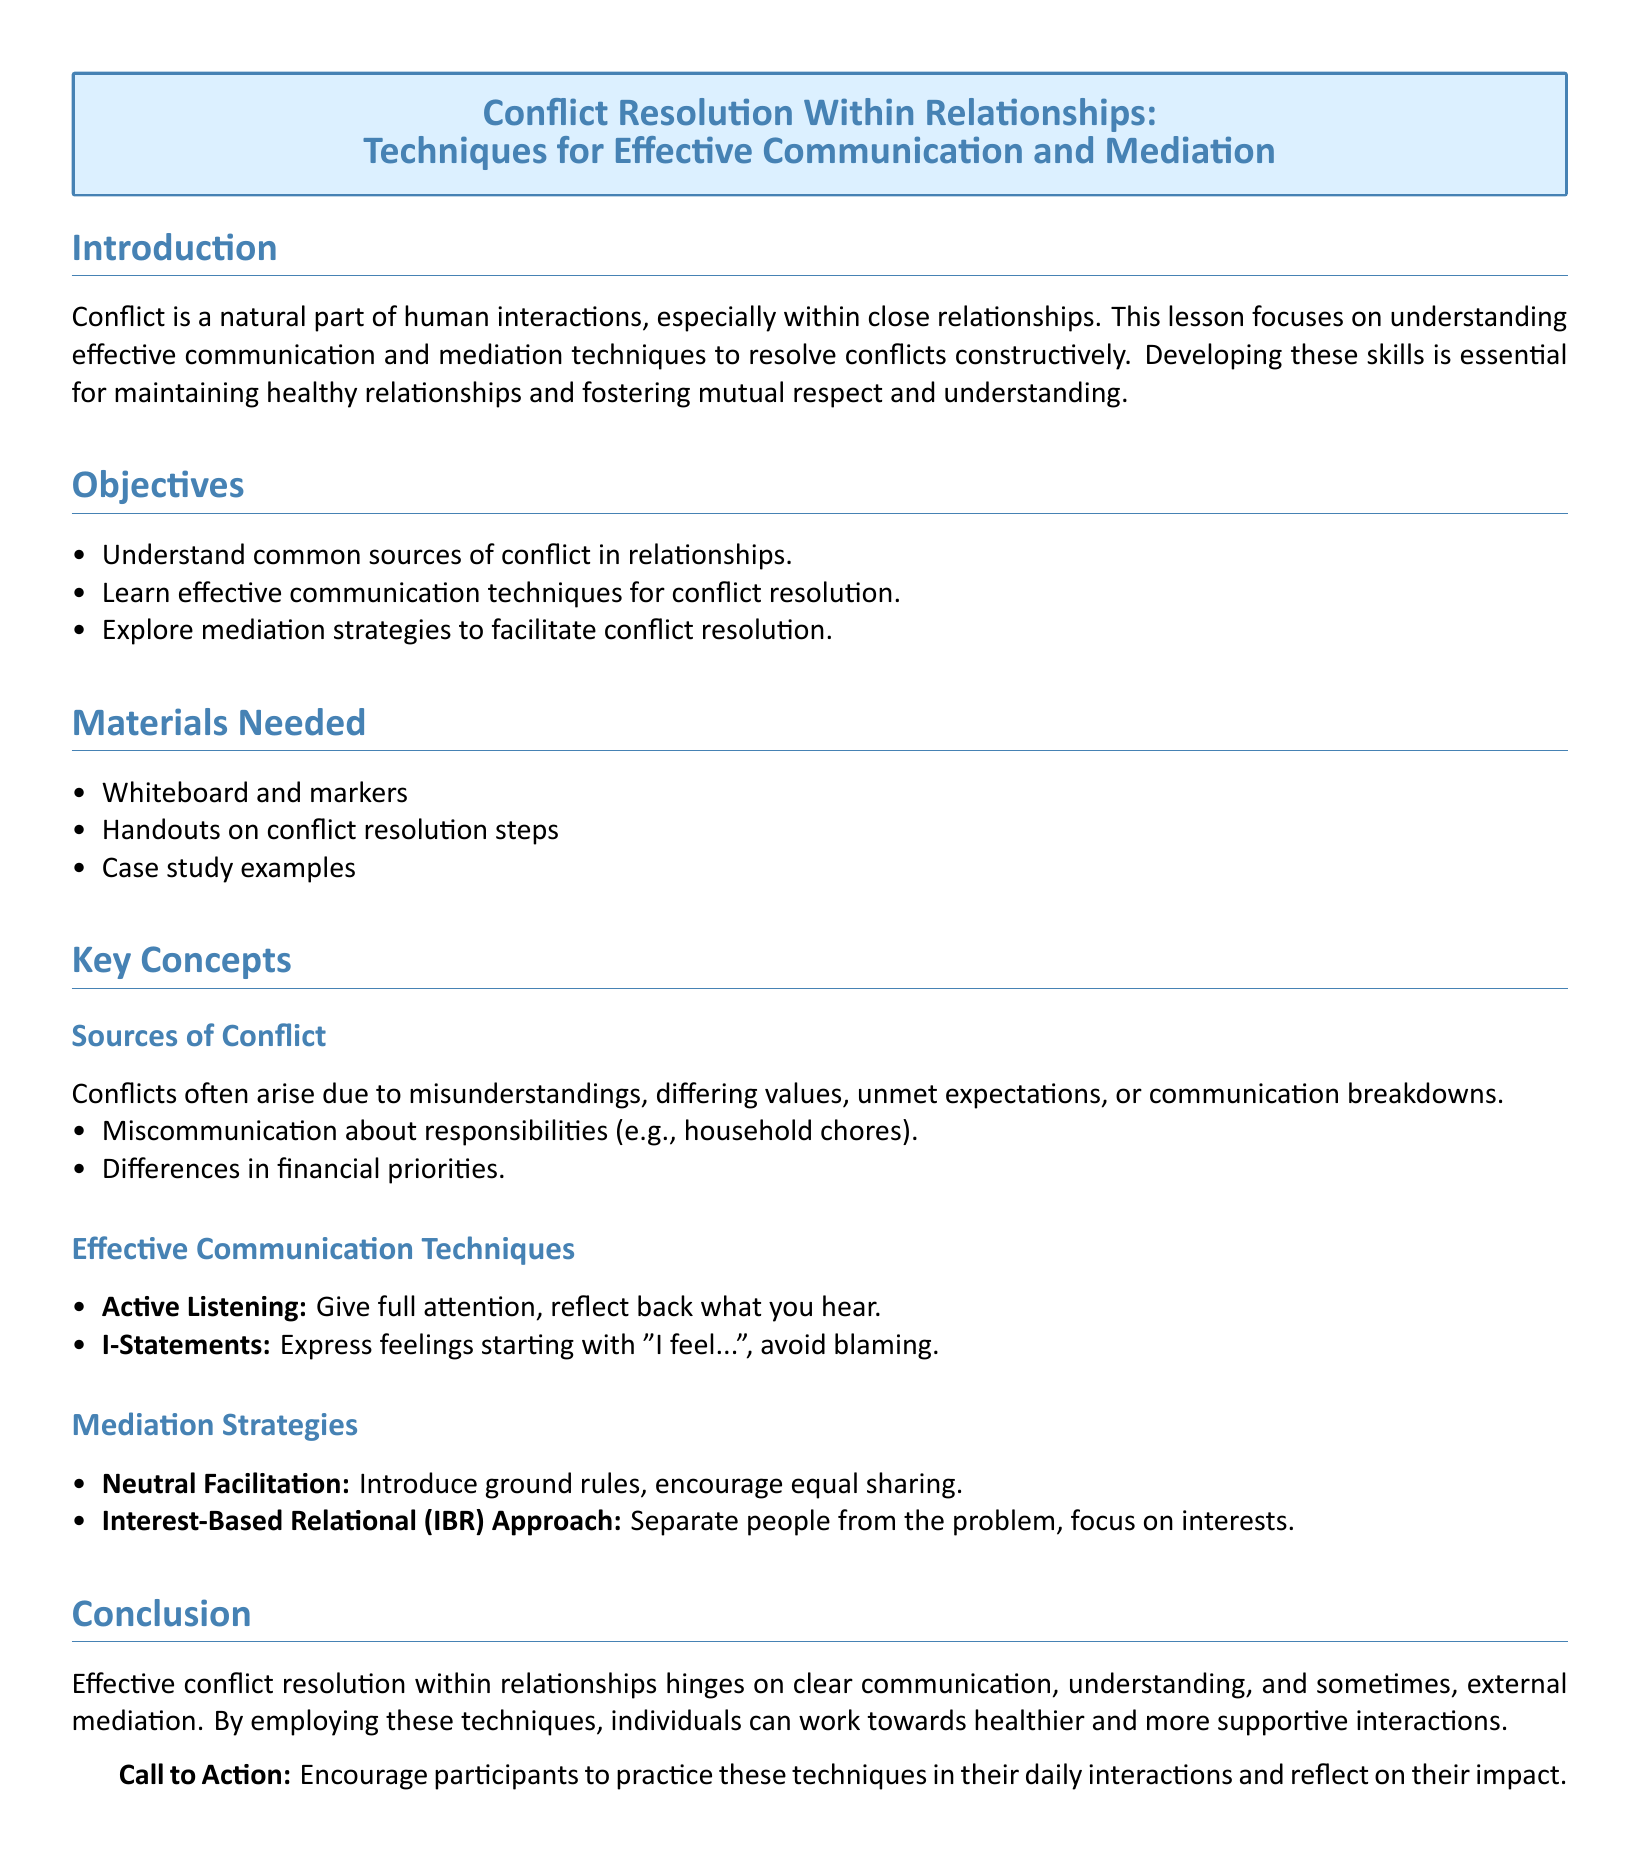what is the title of the lesson? The title is given at the beginning of the document in a highlighted box.
Answer: Conflict Resolution Within Relationships: Techniques for Effective Communication and Mediation what is one key objective of the lesson? One objective is listed under the objectives section of the document.
Answer: Understand common sources of conflict in relationships what materials are needed for the lesson? The materials are found in the materials section, which lists specific items required for the lesson.
Answer: Whiteboard and markers what is an example of a source of conflict? The document provides examples in the sources of conflict subsection.
Answer: Miscommunication about responsibilities name a technique for effective communication mentioned in the lesson. The document lists communication techniques under effective communication techniques.
Answer: Active Listening what does I-Statements help to avoid? This is explained in the effective communication techniques section regarding the concept of I-Statements.
Answer: Blaming what is a mediation strategy mentioned? The document highlights specific mediation strategies in its subsections.
Answer: Neutral Facilitation what are participants encouraged to do after the lesson? The conclusion has a call to action prompting participants' next steps.
Answer: Practice these techniques what does the IBR approach focus on? The IBR approach's focus is outlined in the mediation strategies section.
Answer: Interests 